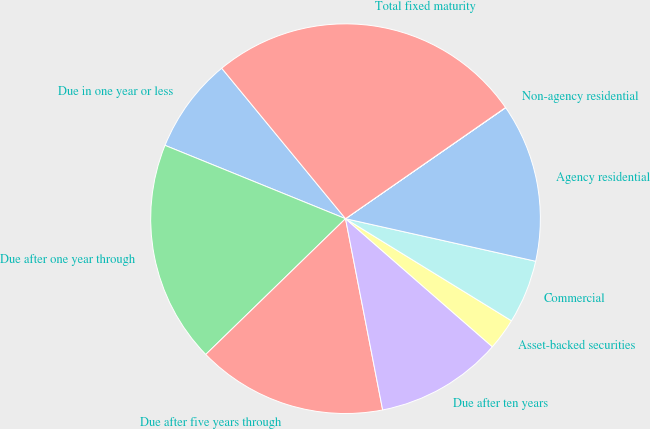<chart> <loc_0><loc_0><loc_500><loc_500><pie_chart><fcel>Due in one year or less<fcel>Due after one year through<fcel>Due after five years through<fcel>Due after ten years<fcel>Asset-backed securities<fcel>Commercial<fcel>Agency residential<fcel>Non-agency residential<fcel>Total fixed maturity<nl><fcel>7.9%<fcel>18.41%<fcel>15.78%<fcel>10.53%<fcel>2.64%<fcel>5.27%<fcel>13.15%<fcel>0.02%<fcel>26.29%<nl></chart> 